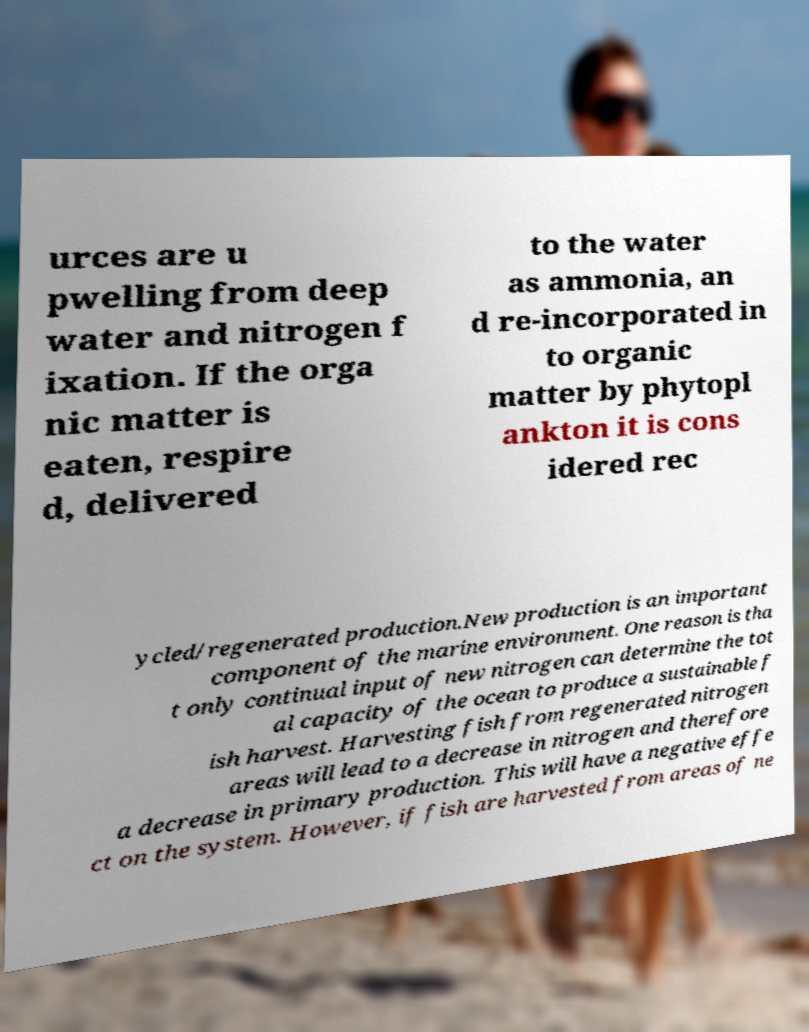There's text embedded in this image that I need extracted. Can you transcribe it verbatim? urces are u pwelling from deep water and nitrogen f ixation. If the orga nic matter is eaten, respire d, delivered to the water as ammonia, an d re-incorporated in to organic matter by phytopl ankton it is cons idered rec ycled/regenerated production.New production is an important component of the marine environment. One reason is tha t only continual input of new nitrogen can determine the tot al capacity of the ocean to produce a sustainable f ish harvest. Harvesting fish from regenerated nitrogen areas will lead to a decrease in nitrogen and therefore a decrease in primary production. This will have a negative effe ct on the system. However, if fish are harvested from areas of ne 